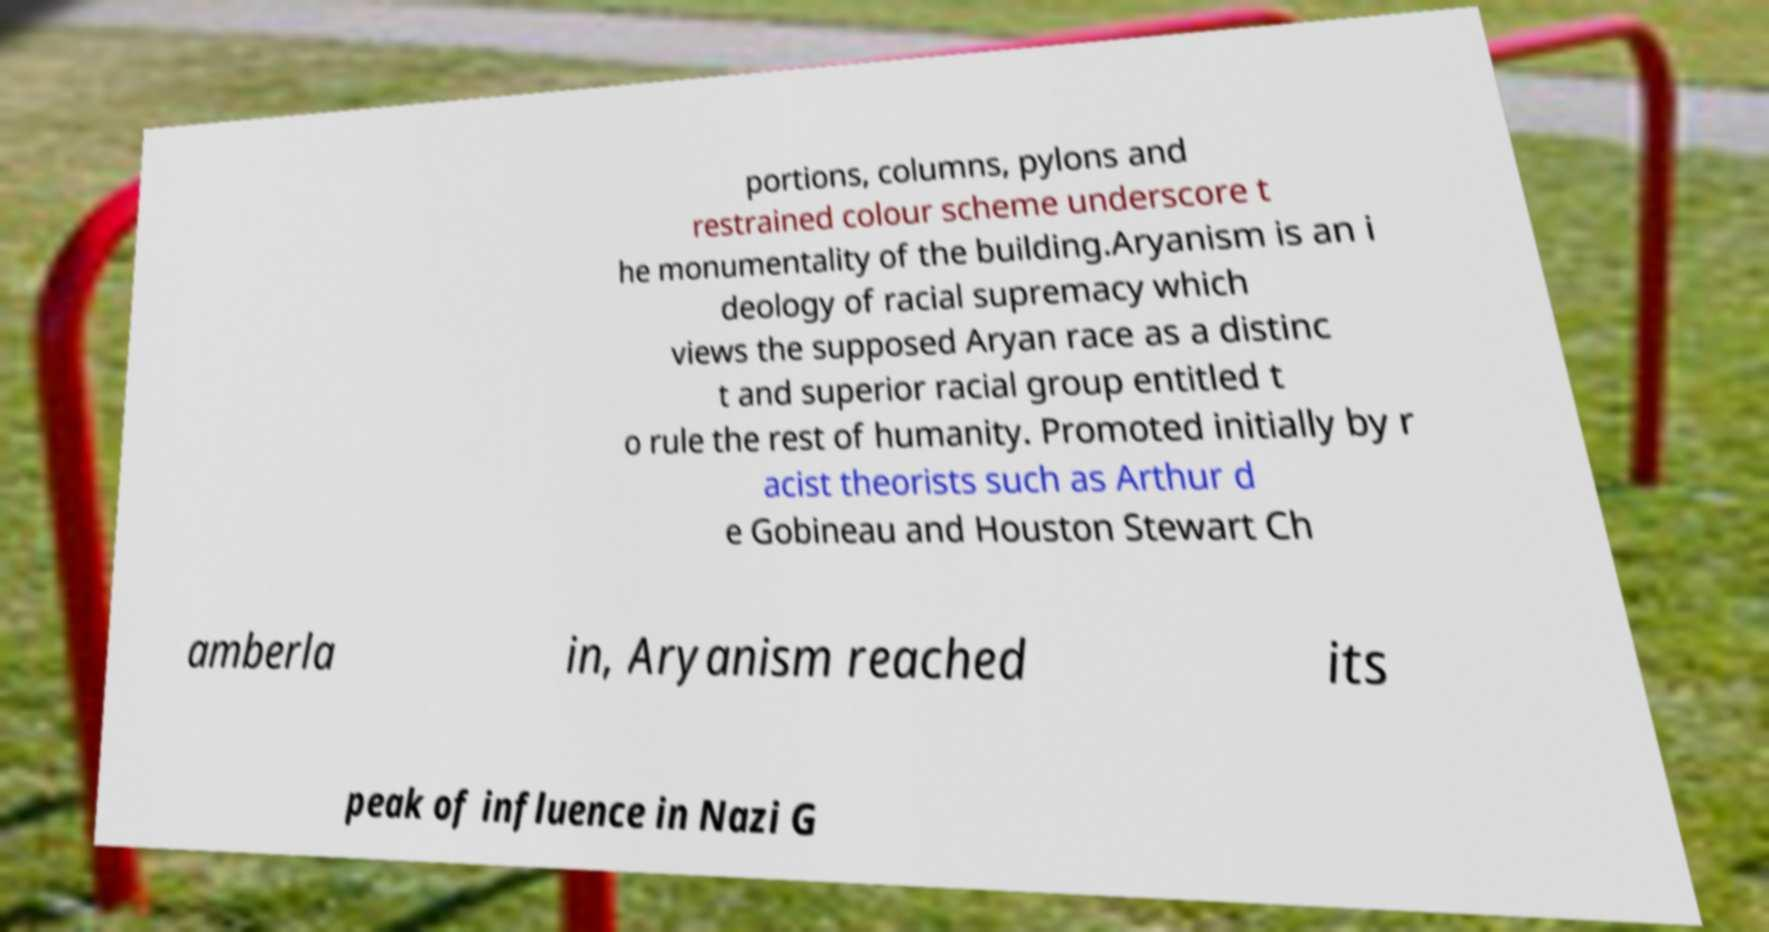Could you extract and type out the text from this image? portions, columns, pylons and restrained colour scheme underscore t he monumentality of the building.Aryanism is an i deology of racial supremacy which views the supposed Aryan race as a distinc t and superior racial group entitled t o rule the rest of humanity. Promoted initially by r acist theorists such as Arthur d e Gobineau and Houston Stewart Ch amberla in, Aryanism reached its peak of influence in Nazi G 